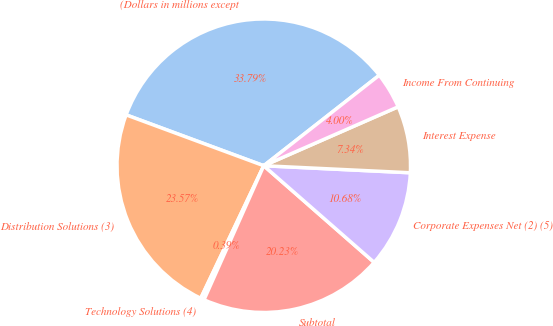<chart> <loc_0><loc_0><loc_500><loc_500><pie_chart><fcel>(Dollars in millions except<fcel>Distribution Solutions (3)<fcel>Technology Solutions (4)<fcel>Subtotal<fcel>Corporate Expenses Net (2) (5)<fcel>Interest Expense<fcel>Income From Continuing<nl><fcel>33.79%<fcel>23.57%<fcel>0.39%<fcel>20.23%<fcel>10.68%<fcel>7.34%<fcel>4.0%<nl></chart> 